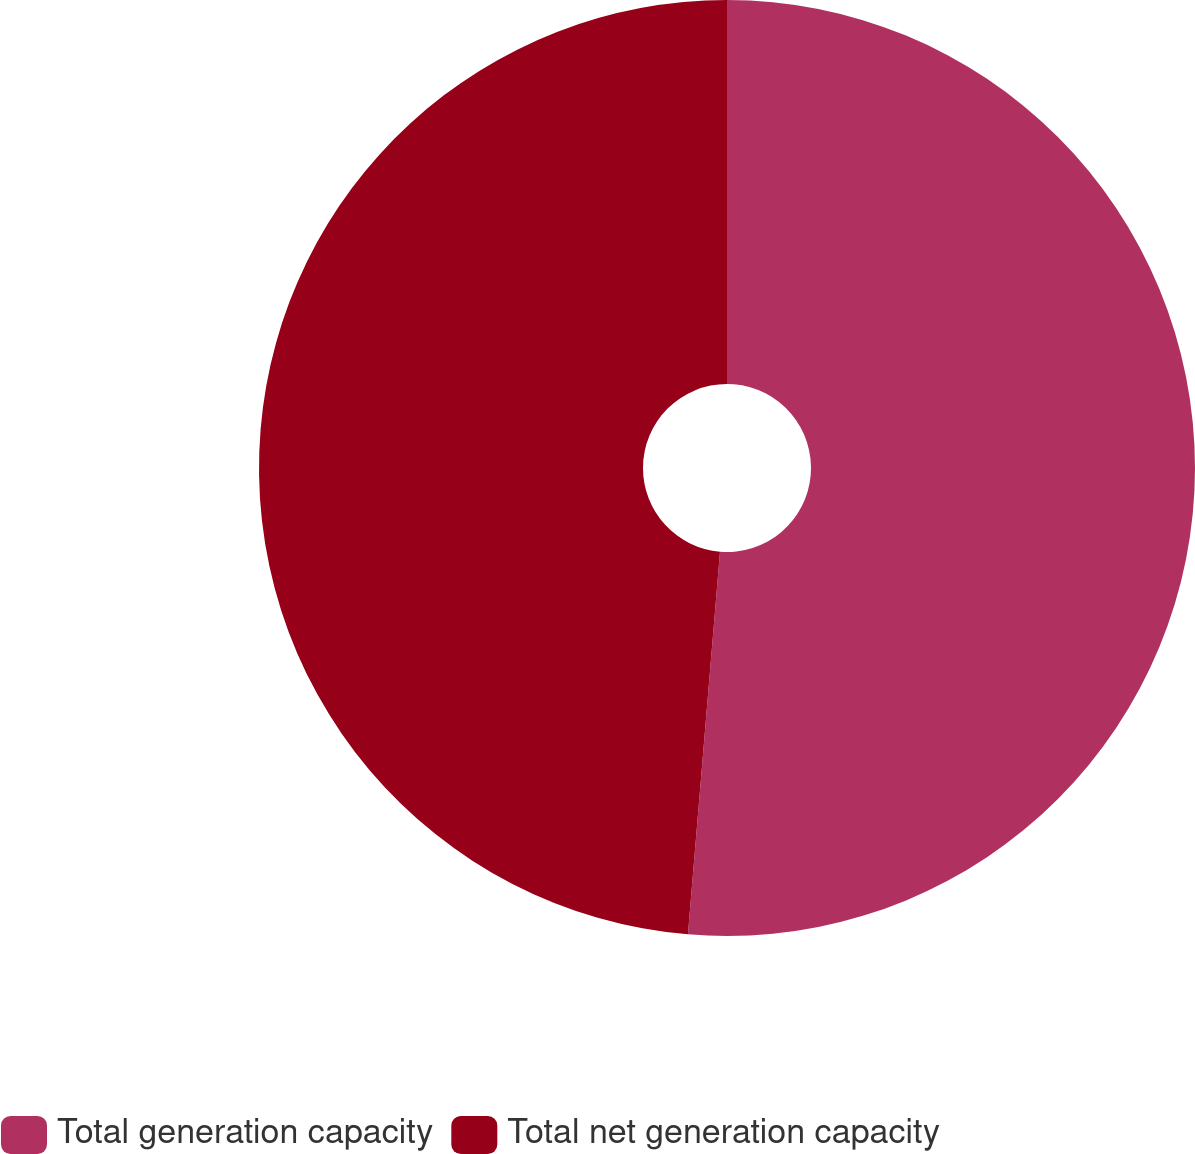Convert chart. <chart><loc_0><loc_0><loc_500><loc_500><pie_chart><fcel>Total generation capacity<fcel>Total net generation capacity<nl><fcel>51.33%<fcel>48.67%<nl></chart> 